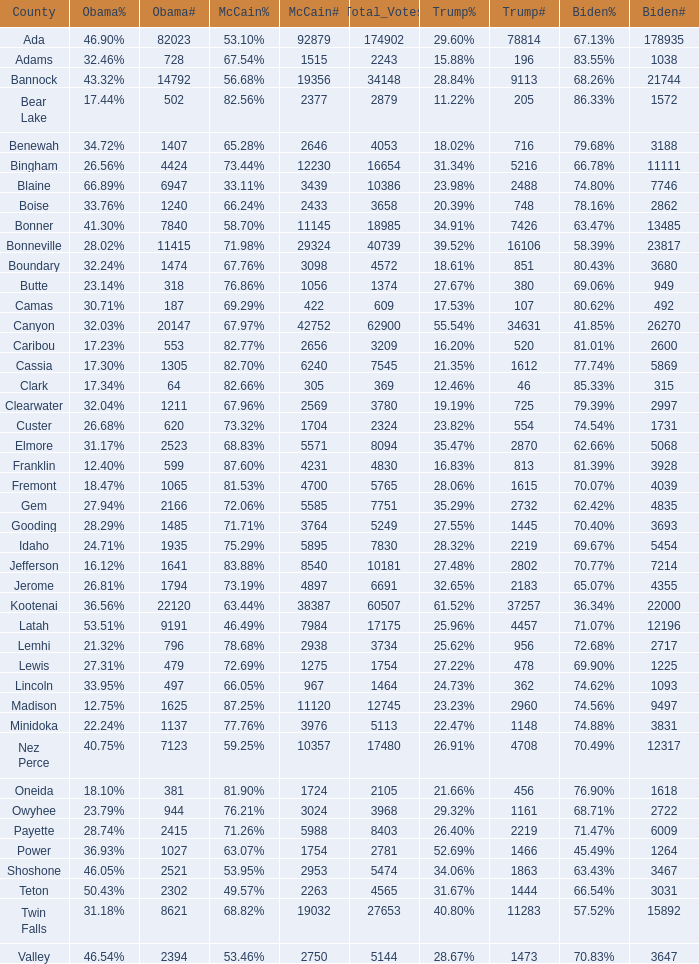What is the McCain vote percentage in Jerome county? 73.19%. 